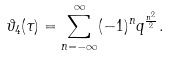<formula> <loc_0><loc_0><loc_500><loc_500>\vartheta _ { 4 } ( \tau ) = \sum _ { n = - \infty } ^ { \infty } ( - 1 ) ^ { n } q ^ { \frac { n ^ { 2 } } { 2 } } .</formula> 